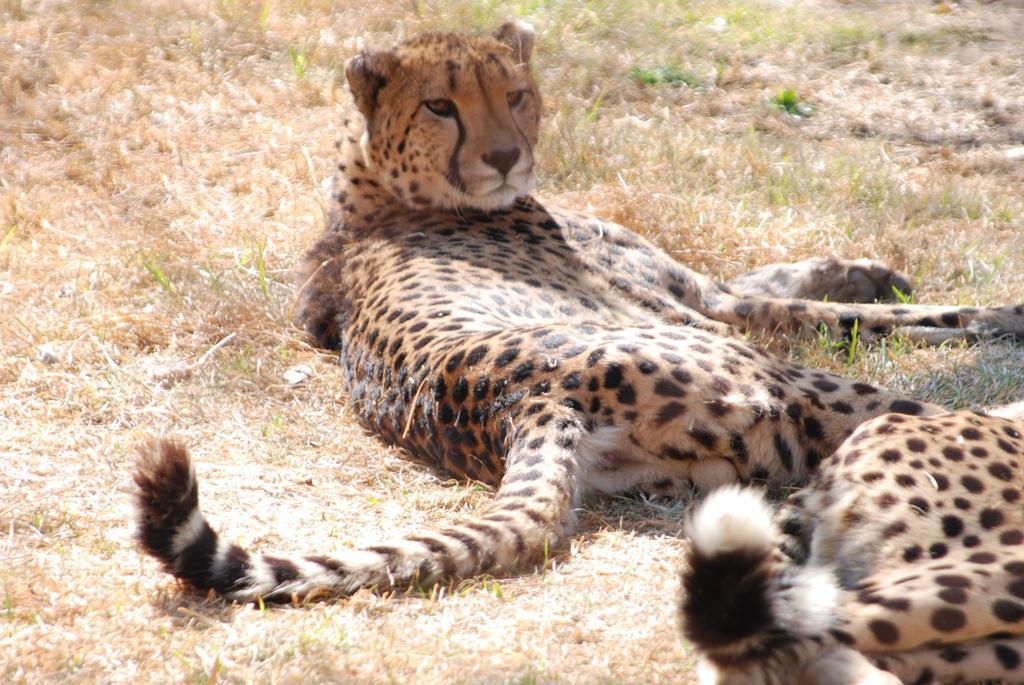In one or two sentences, can you explain what this image depicts? In this image I can see the animals on the ground. 